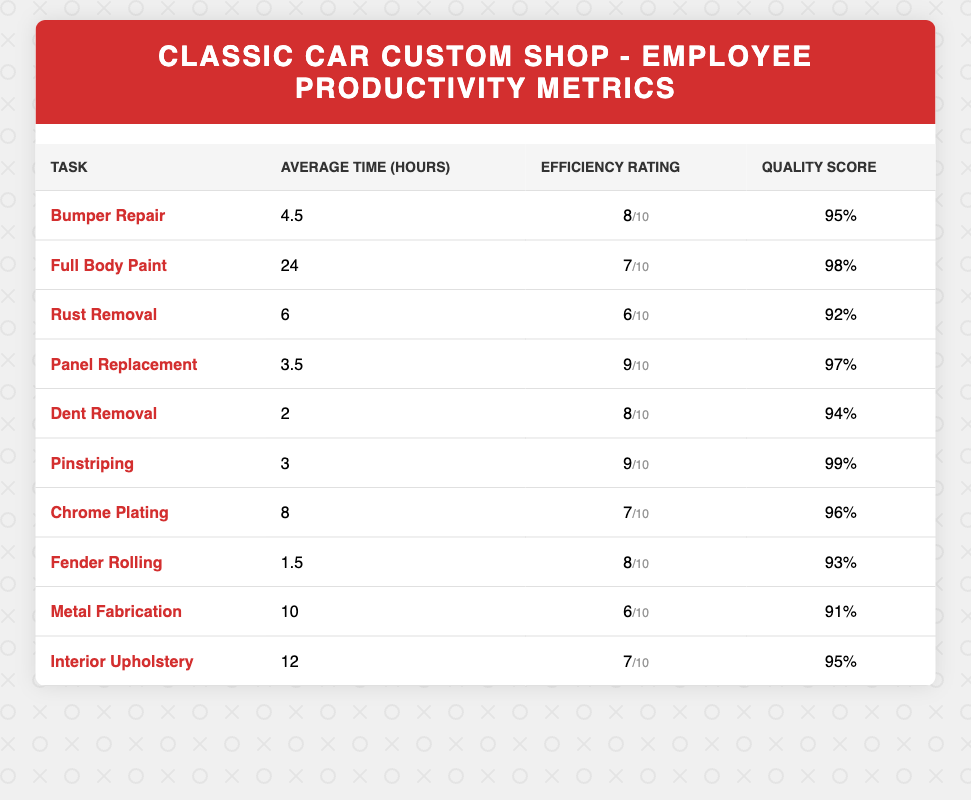What is the average time for panel replacement? The table shows that the average time for panel replacement is listed directly under the "Average Time (hours)" column next to "Panel Replacement," which is 3.5 hours.
Answer: 3.5 Which task has the highest quality score? By looking at the "Quality Score (%)" column, we can see that "Pinstriping" has the highest score of 99%.
Answer: Pinstriping What is the efficiency rating for rust removal? The "Efficiency Rating (1-10)" column shows that the efficiency rating for rust removal is 6, as indicated in the row for "Rust Removal."
Answer: 6 Is the average time for fender rolling less than that for dent removal? The average time for fender rolling is 1.5 hours, while the average time for dent removal is 2 hours. Since 1.5 is less than 2, the statement is true.
Answer: Yes What is the combined average time for chrome plating and metal fabrication? To find the combined average time, we add the average times for chrome plating (8 hours) and metal fabrication (10 hours): 8 + 10 = 18 hours. Then we divide by 2 to find the average: 18/2 = 9 hours.
Answer: 9 Which task has both an efficiency rating and quality score above 90%? Looking through the table, we find "Bumper Repair" with an efficiency rating of 8 and a quality score of 95, which are both above 90%.
Answer: Yes What is the median efficiency rating of all tasks listed? The efficiency ratings are: 8, 7, 6, 9, 8, 9, 7, 8, 6, 7. To find the median, we first arrange the numbers in order: 6, 6, 7, 7, 7, 8, 8, 8, 9, 9. Since there are 10 values, the median is the average of the 5th and 6th values: (7 + 8)/2 = 7.5.
Answer: 7.5 Which task has the lowest quality score? By checking the "Quality Score (%)" column, "Metal Fabrication" has the lowest score at 91%, as seen in its row.
Answer: Metal Fabrication What is the difference between the highest and lowest efficiency ratings? The highest efficiency rating in the table is 9 (for Panel Replacement and Pinstriping), and the lowest is 6 (for Rust Removal and Metal Fabrication). The difference is calculated as 9 - 6 = 3.
Answer: 3 